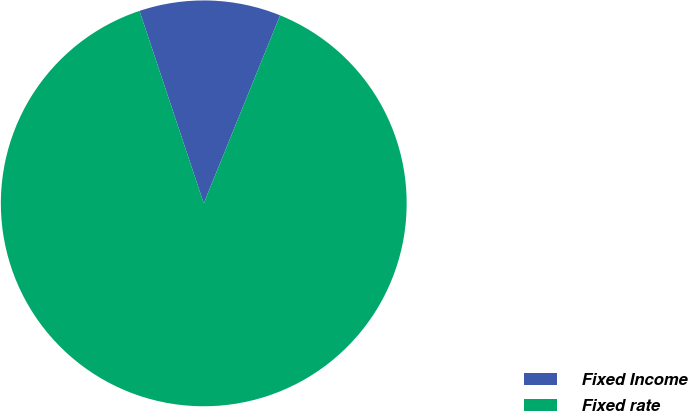Convert chart. <chart><loc_0><loc_0><loc_500><loc_500><pie_chart><fcel>Fixed Income<fcel>Fixed rate<nl><fcel>11.27%<fcel>88.73%<nl></chart> 